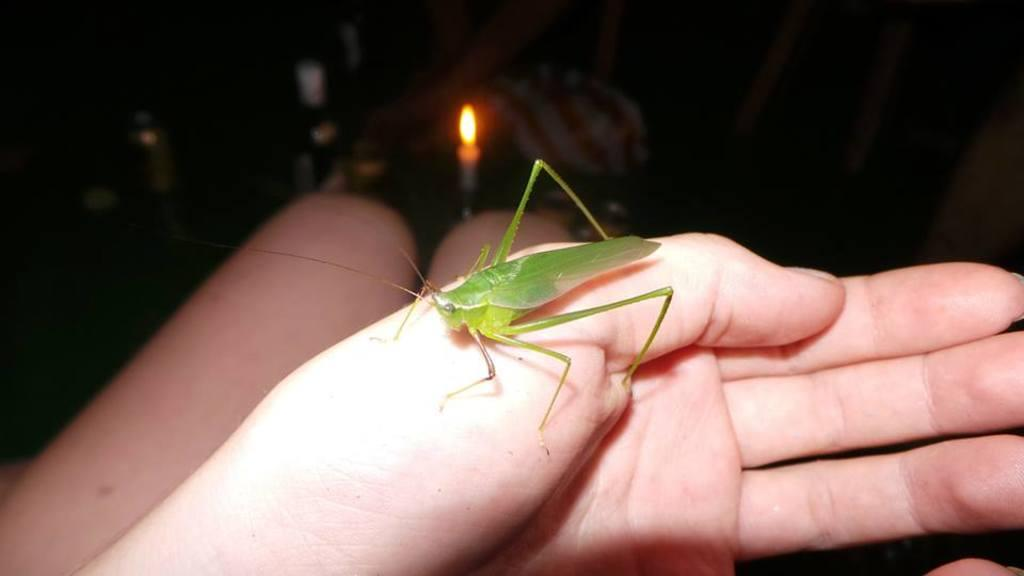What body parts of a person are visible in the image? There are two legs and a hand of a person in the image. What is on the hand of the person? There is a grasshopper on the hand. What can be seen in the background of the image? There are bottles and a candle in the background of the image. How many cent coins are visible on the grasshopper's back in the image? There are no cent coins visible on the grasshopper's back in the image. 